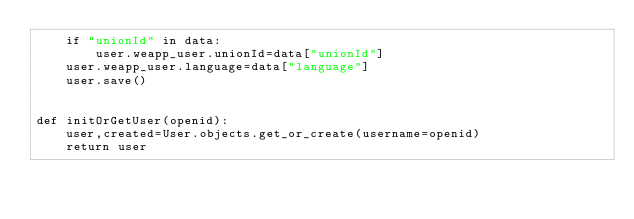Convert code to text. <code><loc_0><loc_0><loc_500><loc_500><_Python_>    if "unionId" in data:
        user.weapp_user.unionId=data["unionId"]
    user.weapp_user.language=data["language"]
    user.save()


def initOrGetUser(openid):
    user,created=User.objects.get_or_create(username=openid)
    return user</code> 